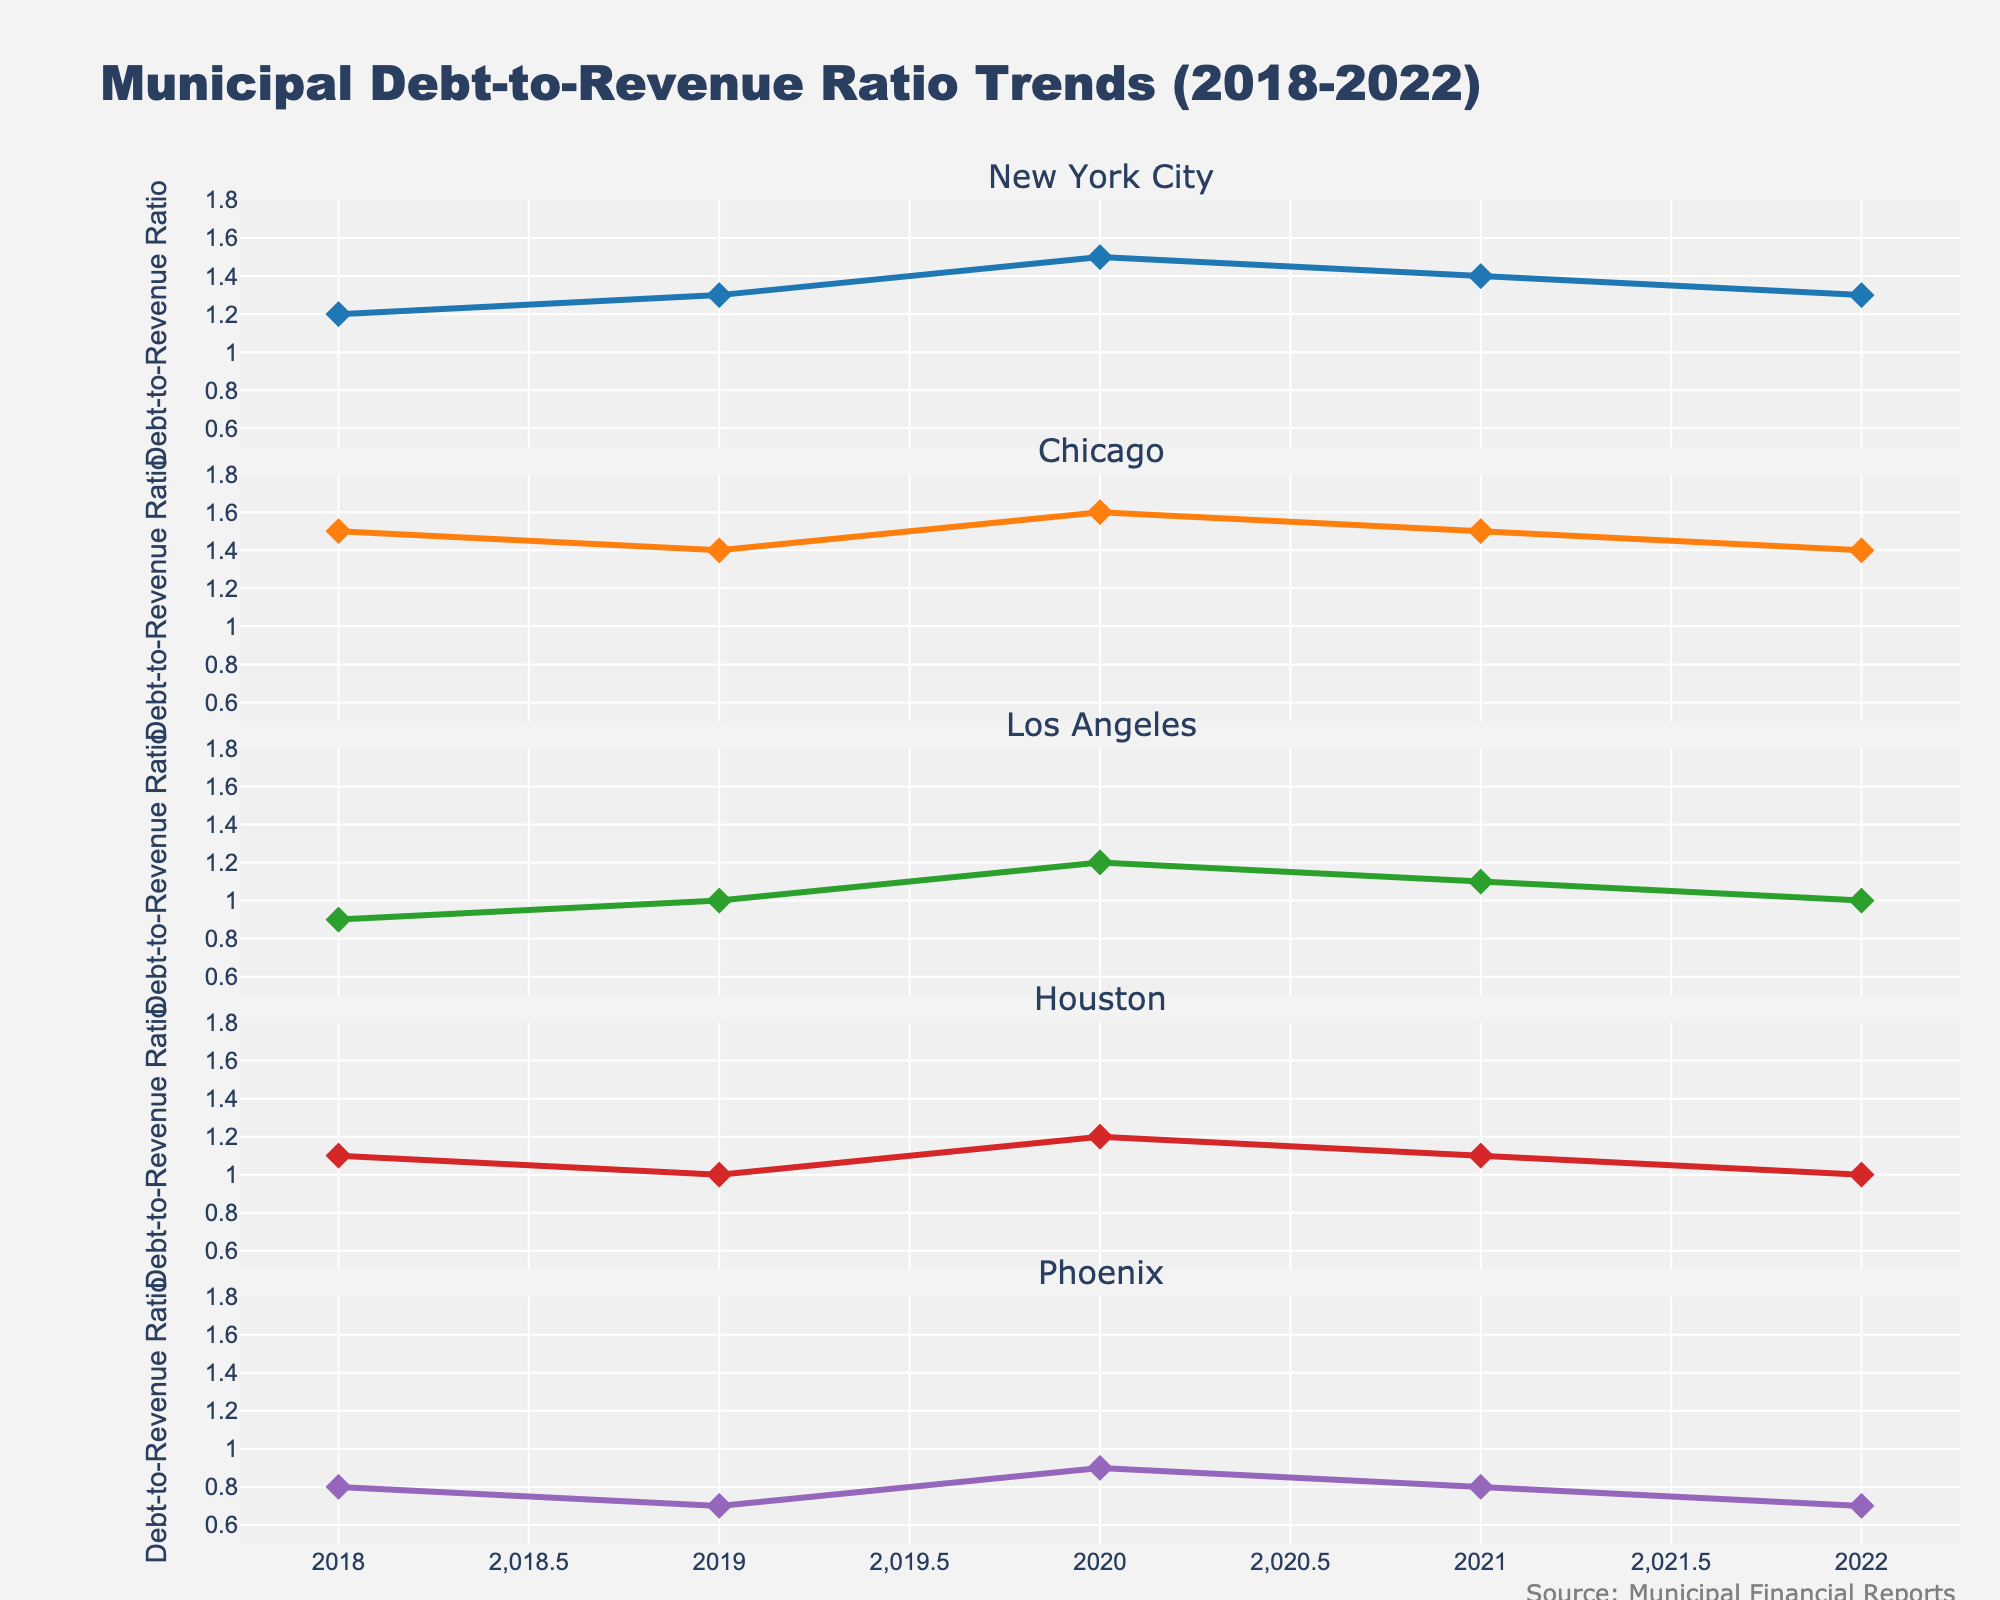What's the title of the figure? The title of the figure is prominently displayed at the top. It helps to understand what the figure represents.
Answer: Municipal Debt-to-Revenue Ratio Trends (2018-2022) What is the debt-to-revenue ratio for New York City in 2020? Look at the New York City subplot and identify the point for the year 2020. The ratio is indicated by the point's y-value.
Answer: 1.5 Which city has the lowest debt-to-revenue ratio in 2022? Identify the 2022 data points in each subplot and compare their y-values. The lowest value indicates the lowest ratio.
Answer: Phoenix How did the debt-to-revenue ratio for Chicago change from 2018 to 2022? Check the Chicago subplot for the y-values in 2018 and 2022. Observe the change from the starting to the ending value.
Answer: It decreased from 1.5 to 1.4 What is the average debt-to-revenue ratio for Houston across the years 2018 to 2022? Calculate the sum of Houston's ratios for each year and divide by the number of years (5). The average is (1.1 + 1.0 + 1.2 + 1.1 + 1.0)/5.
Answer: 1.08 Between Los Angeles and New York City, which city showed a greater increase in debt-to-revenue ratio from 2018 to 2020? Check both subplots for each city's 2018 and 2020 values, then calculate their increases (New York City: 1.5 - 1.2, Los Angeles: 1.2 - 0.9), and compare.
Answer: Los Angeles increased by 0.3 and New York City increased by 0.3 What trend do you notice in the debt-to-revenue ratio for Phoenix from 2018 to 2022? Follow the line in the Phoenix subplot from 2018 to 2022 and describe the overall direction.
Answer: Decreasing trend Which city experienced the most fluctuation in its debt-to-revenue ratio over the five-year period? Examine each subplot to find the city with the greatest differences between its highest and lowest points.
Answer: New York City (fluctuates between 1.5 and 1.2) Did any city’s debt-to-revenue ratio remain constant for any two consecutive years? If so, which city and which years? Check each city’s subplot for consecutive points that have the same y-values.
Answer: Chicago (2019 and 2020, ratio of 1.4), Phoenix (2018 and 2019, ratio of 0.8) Is there any year where all cities had a debt-to-revenue ratio below 1.5? Check each city's ratio for every year and find if there is any year where all values are below 1.5.
Answer: Yes, in 2021 and 2022 Which city had the highest debt-to-revenue ratio in any year, and what was the ratio? Search all subplots to find the maximum y-value across all years and cities.
Answer: Chicago in 2020 with a ratio of 1.6 